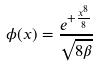<formula> <loc_0><loc_0><loc_500><loc_500>\phi ( x ) = \frac { e ^ { + \frac { x ^ { 8 } } { 8 } } } { \sqrt { 8 \beta } }</formula> 